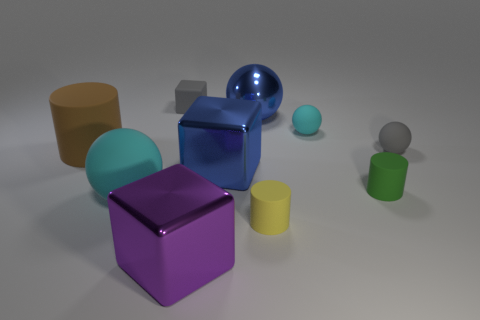The tiny gray object that is left of the yellow object has what shape?
Provide a short and direct response. Cube. How many objects are on the right side of the yellow cylinder and left of the gray rubber block?
Provide a succinct answer. 0. What number of other objects are there of the same size as the gray matte cube?
Offer a terse response. 4. Does the cyan matte object behind the tiny green cylinder have the same shape as the gray rubber thing that is in front of the big shiny ball?
Offer a terse response. Yes. How many things are either yellow rubber cylinders or small objects to the right of the big metallic sphere?
Provide a short and direct response. 4. There is a thing that is to the left of the large blue sphere and in front of the large matte ball; what material is it made of?
Your answer should be compact. Metal. Are there any other things that have the same shape as the purple metal object?
Your answer should be compact. Yes. There is a big sphere that is made of the same material as the tiny green cylinder; what color is it?
Offer a terse response. Cyan. How many things are blue metallic blocks or gray cubes?
Provide a succinct answer. 2. There is a gray matte block; is its size the same as the metallic cube that is behind the tiny yellow rubber thing?
Your response must be concise. No. 